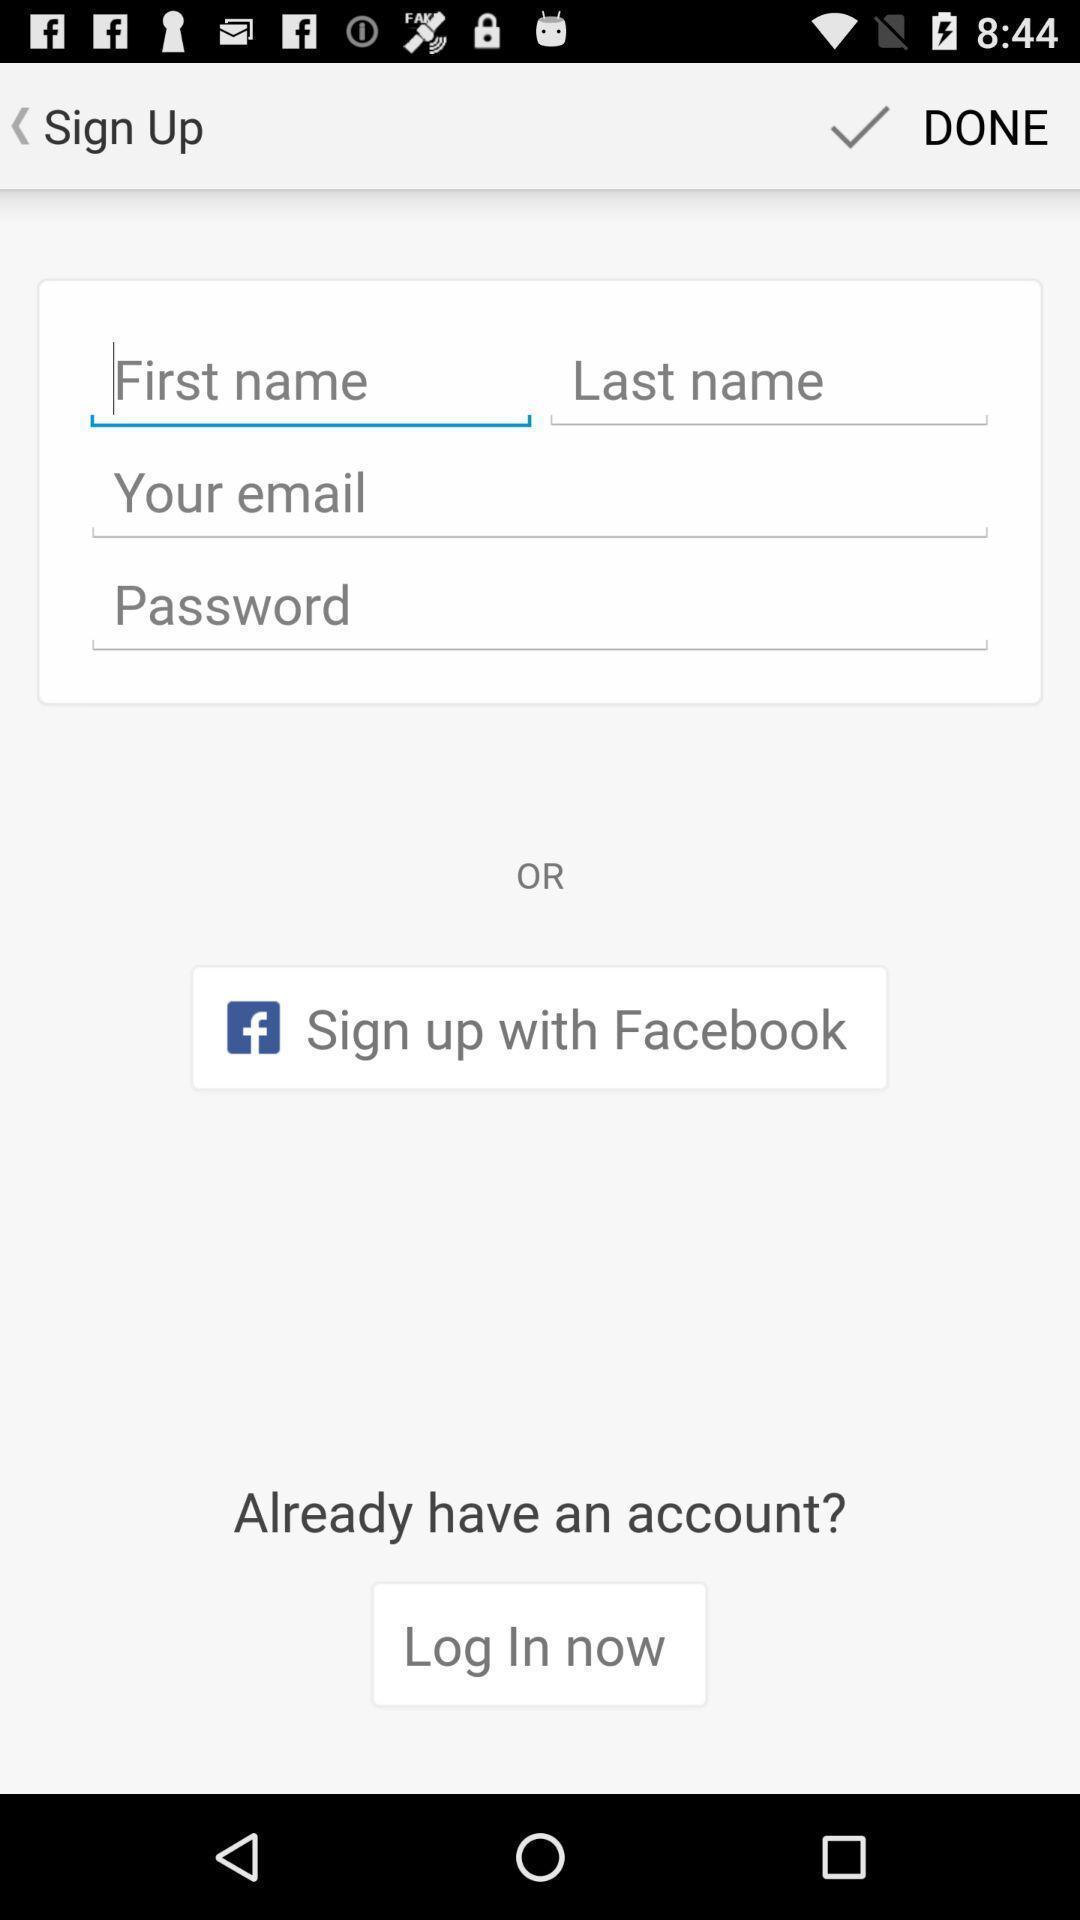Describe the content in this image. Welcome page of a social app. 